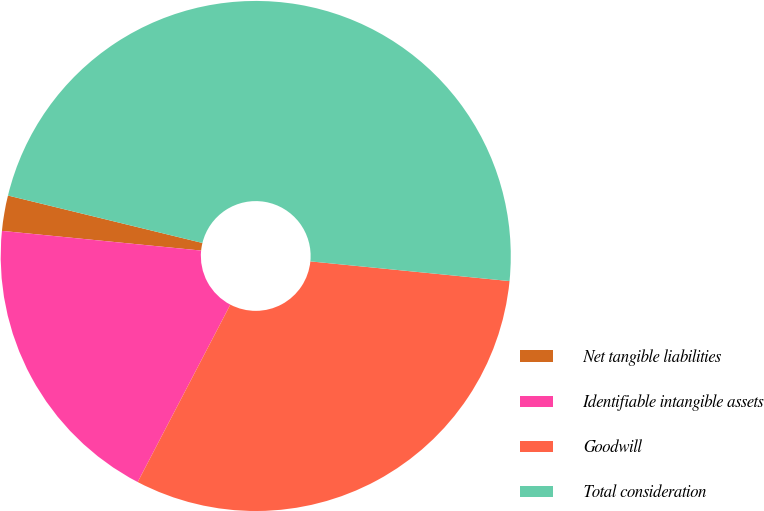<chart> <loc_0><loc_0><loc_500><loc_500><pie_chart><fcel>Net tangible liabilities<fcel>Identifiable intangible assets<fcel>Goodwill<fcel>Total consideration<nl><fcel>2.24%<fcel>18.91%<fcel>31.09%<fcel>47.76%<nl></chart> 